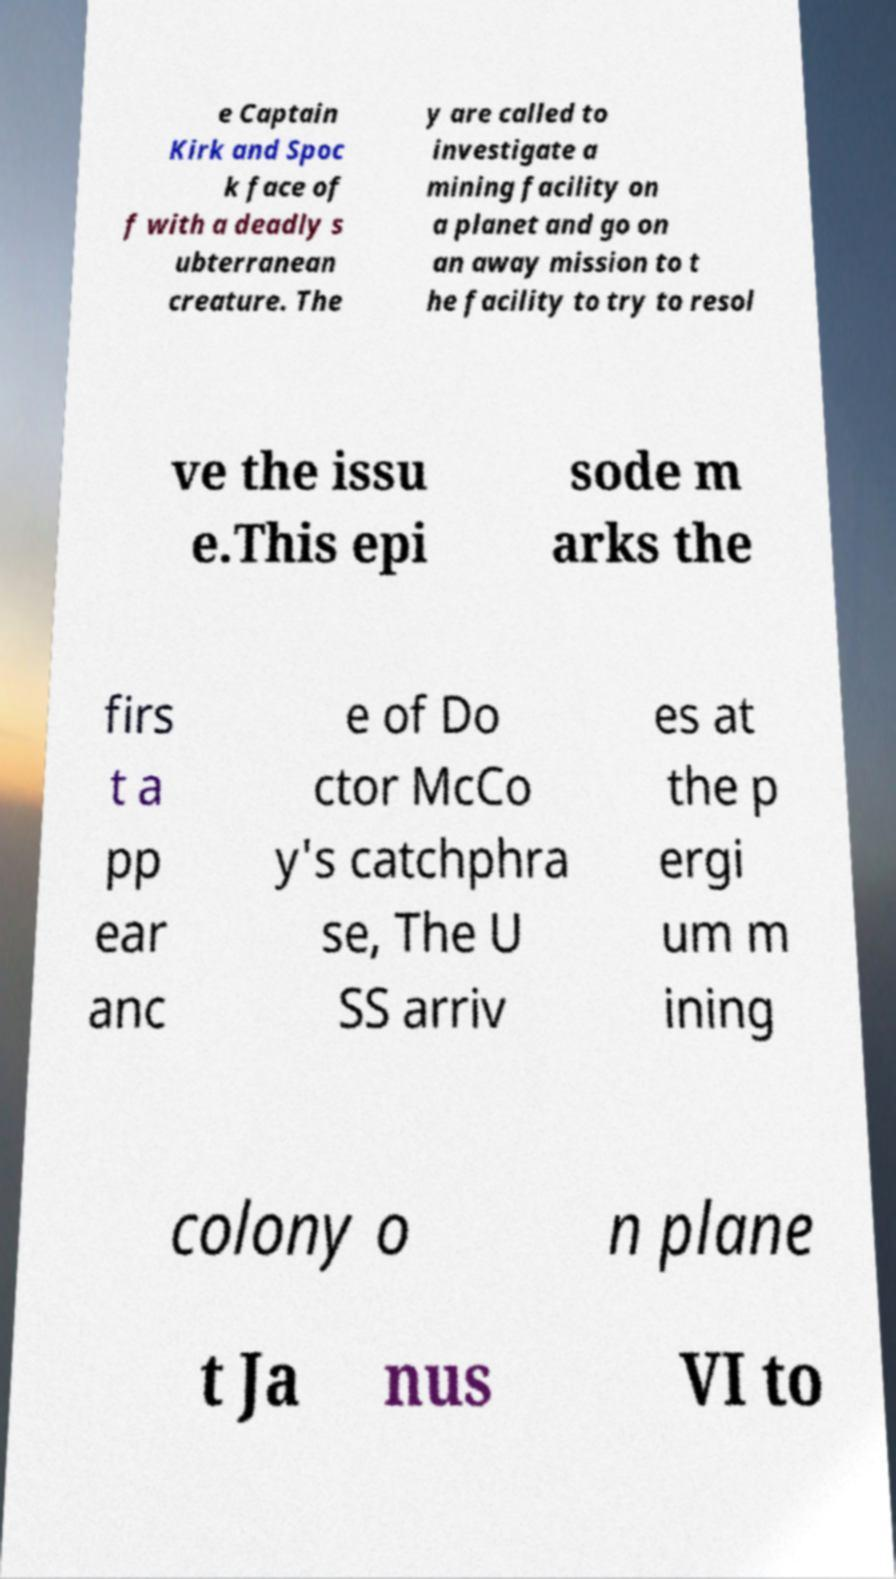I need the written content from this picture converted into text. Can you do that? e Captain Kirk and Spoc k face of f with a deadly s ubterranean creature. The y are called to investigate a mining facility on a planet and go on an away mission to t he facility to try to resol ve the issu e.This epi sode m arks the firs t a pp ear anc e of Do ctor McCo y's catchphra se, The U SS arriv es at the p ergi um m ining colony o n plane t Ja nus VI to 